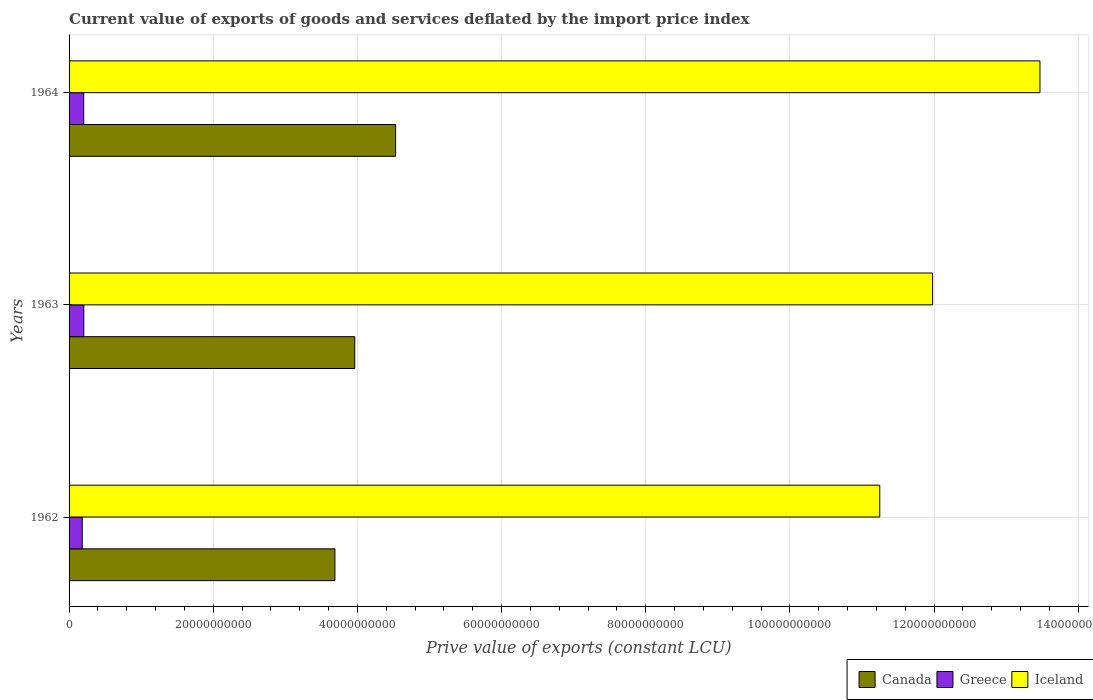How many different coloured bars are there?
Make the answer very short. 3. What is the label of the 2nd group of bars from the top?
Your answer should be very brief. 1963. What is the prive value of exports in Greece in 1963?
Provide a succinct answer. 2.04e+09. Across all years, what is the maximum prive value of exports in Canada?
Provide a short and direct response. 4.53e+1. Across all years, what is the minimum prive value of exports in Canada?
Provide a short and direct response. 3.69e+1. In which year was the prive value of exports in Greece maximum?
Your answer should be compact. 1963. What is the total prive value of exports in Iceland in the graph?
Keep it short and to the point. 3.67e+11. What is the difference between the prive value of exports in Iceland in 1962 and that in 1964?
Offer a very short reply. -2.22e+1. What is the difference between the prive value of exports in Canada in 1964 and the prive value of exports in Greece in 1963?
Give a very brief answer. 4.33e+1. What is the average prive value of exports in Canada per year?
Your answer should be very brief. 4.06e+1. In the year 1963, what is the difference between the prive value of exports in Canada and prive value of exports in Greece?
Keep it short and to the point. 3.76e+1. In how many years, is the prive value of exports in Greece greater than 44000000000 LCU?
Provide a succinct answer. 0. What is the ratio of the prive value of exports in Canada in 1963 to that in 1964?
Provide a short and direct response. 0.87. Is the prive value of exports in Iceland in 1963 less than that in 1964?
Ensure brevity in your answer.  Yes. What is the difference between the highest and the second highest prive value of exports in Greece?
Offer a terse response. 9.09e+06. What is the difference between the highest and the lowest prive value of exports in Iceland?
Give a very brief answer. 2.22e+1. In how many years, is the prive value of exports in Iceland greater than the average prive value of exports in Iceland taken over all years?
Your answer should be compact. 1. What does the 3rd bar from the bottom in 1964 represents?
Keep it short and to the point. Iceland. Is it the case that in every year, the sum of the prive value of exports in Iceland and prive value of exports in Greece is greater than the prive value of exports in Canada?
Your answer should be compact. Yes. How many bars are there?
Provide a short and direct response. 9. Are all the bars in the graph horizontal?
Provide a succinct answer. Yes. How many years are there in the graph?
Make the answer very short. 3. Are the values on the major ticks of X-axis written in scientific E-notation?
Offer a terse response. No. Does the graph contain any zero values?
Offer a terse response. No. Does the graph contain grids?
Your response must be concise. Yes. Where does the legend appear in the graph?
Ensure brevity in your answer.  Bottom right. How many legend labels are there?
Keep it short and to the point. 3. What is the title of the graph?
Offer a terse response. Current value of exports of goods and services deflated by the import price index. Does "Denmark" appear as one of the legend labels in the graph?
Make the answer very short. No. What is the label or title of the X-axis?
Your response must be concise. Prive value of exports (constant LCU). What is the label or title of the Y-axis?
Provide a short and direct response. Years. What is the Prive value of exports (constant LCU) in Canada in 1962?
Ensure brevity in your answer.  3.69e+1. What is the Prive value of exports (constant LCU) of Greece in 1962?
Your response must be concise. 1.83e+09. What is the Prive value of exports (constant LCU) in Iceland in 1962?
Make the answer very short. 1.12e+11. What is the Prive value of exports (constant LCU) in Canada in 1963?
Offer a very short reply. 3.96e+1. What is the Prive value of exports (constant LCU) of Greece in 1963?
Offer a terse response. 2.04e+09. What is the Prive value of exports (constant LCU) in Iceland in 1963?
Offer a very short reply. 1.20e+11. What is the Prive value of exports (constant LCU) of Canada in 1964?
Offer a terse response. 4.53e+1. What is the Prive value of exports (constant LCU) in Greece in 1964?
Your response must be concise. 2.03e+09. What is the Prive value of exports (constant LCU) in Iceland in 1964?
Your answer should be very brief. 1.35e+11. Across all years, what is the maximum Prive value of exports (constant LCU) in Canada?
Your answer should be very brief. 4.53e+1. Across all years, what is the maximum Prive value of exports (constant LCU) in Greece?
Provide a succinct answer. 2.04e+09. Across all years, what is the maximum Prive value of exports (constant LCU) in Iceland?
Your answer should be very brief. 1.35e+11. Across all years, what is the minimum Prive value of exports (constant LCU) of Canada?
Give a very brief answer. 3.69e+1. Across all years, what is the minimum Prive value of exports (constant LCU) in Greece?
Keep it short and to the point. 1.83e+09. Across all years, what is the minimum Prive value of exports (constant LCU) in Iceland?
Your answer should be compact. 1.12e+11. What is the total Prive value of exports (constant LCU) of Canada in the graph?
Ensure brevity in your answer.  1.22e+11. What is the total Prive value of exports (constant LCU) of Greece in the graph?
Ensure brevity in your answer.  5.90e+09. What is the total Prive value of exports (constant LCU) of Iceland in the graph?
Provide a succinct answer. 3.67e+11. What is the difference between the Prive value of exports (constant LCU) in Canada in 1962 and that in 1963?
Make the answer very short. -2.75e+09. What is the difference between the Prive value of exports (constant LCU) of Greece in 1962 and that in 1963?
Ensure brevity in your answer.  -2.17e+08. What is the difference between the Prive value of exports (constant LCU) in Iceland in 1962 and that in 1963?
Give a very brief answer. -7.33e+09. What is the difference between the Prive value of exports (constant LCU) in Canada in 1962 and that in 1964?
Provide a succinct answer. -8.42e+09. What is the difference between the Prive value of exports (constant LCU) in Greece in 1962 and that in 1964?
Your answer should be very brief. -2.08e+08. What is the difference between the Prive value of exports (constant LCU) in Iceland in 1962 and that in 1964?
Offer a very short reply. -2.22e+1. What is the difference between the Prive value of exports (constant LCU) in Canada in 1963 and that in 1964?
Provide a succinct answer. -5.67e+09. What is the difference between the Prive value of exports (constant LCU) of Greece in 1963 and that in 1964?
Provide a succinct answer. 9.09e+06. What is the difference between the Prive value of exports (constant LCU) in Iceland in 1963 and that in 1964?
Make the answer very short. -1.49e+1. What is the difference between the Prive value of exports (constant LCU) in Canada in 1962 and the Prive value of exports (constant LCU) in Greece in 1963?
Give a very brief answer. 3.48e+1. What is the difference between the Prive value of exports (constant LCU) of Canada in 1962 and the Prive value of exports (constant LCU) of Iceland in 1963?
Provide a short and direct response. -8.29e+1. What is the difference between the Prive value of exports (constant LCU) of Greece in 1962 and the Prive value of exports (constant LCU) of Iceland in 1963?
Make the answer very short. -1.18e+11. What is the difference between the Prive value of exports (constant LCU) of Canada in 1962 and the Prive value of exports (constant LCU) of Greece in 1964?
Provide a succinct answer. 3.48e+1. What is the difference between the Prive value of exports (constant LCU) of Canada in 1962 and the Prive value of exports (constant LCU) of Iceland in 1964?
Make the answer very short. -9.78e+1. What is the difference between the Prive value of exports (constant LCU) in Greece in 1962 and the Prive value of exports (constant LCU) in Iceland in 1964?
Your answer should be compact. -1.33e+11. What is the difference between the Prive value of exports (constant LCU) in Canada in 1963 and the Prive value of exports (constant LCU) in Greece in 1964?
Ensure brevity in your answer.  3.76e+1. What is the difference between the Prive value of exports (constant LCU) of Canada in 1963 and the Prive value of exports (constant LCU) of Iceland in 1964?
Give a very brief answer. -9.51e+1. What is the difference between the Prive value of exports (constant LCU) of Greece in 1963 and the Prive value of exports (constant LCU) of Iceland in 1964?
Make the answer very short. -1.33e+11. What is the average Prive value of exports (constant LCU) in Canada per year?
Offer a terse response. 4.06e+1. What is the average Prive value of exports (constant LCU) in Greece per year?
Provide a succinct answer. 1.97e+09. What is the average Prive value of exports (constant LCU) of Iceland per year?
Offer a terse response. 1.22e+11. In the year 1962, what is the difference between the Prive value of exports (constant LCU) of Canada and Prive value of exports (constant LCU) of Greece?
Make the answer very short. 3.51e+1. In the year 1962, what is the difference between the Prive value of exports (constant LCU) of Canada and Prive value of exports (constant LCU) of Iceland?
Your answer should be compact. -7.56e+1. In the year 1962, what is the difference between the Prive value of exports (constant LCU) of Greece and Prive value of exports (constant LCU) of Iceland?
Give a very brief answer. -1.11e+11. In the year 1963, what is the difference between the Prive value of exports (constant LCU) in Canada and Prive value of exports (constant LCU) in Greece?
Provide a short and direct response. 3.76e+1. In the year 1963, what is the difference between the Prive value of exports (constant LCU) in Canada and Prive value of exports (constant LCU) in Iceland?
Provide a succinct answer. -8.02e+1. In the year 1963, what is the difference between the Prive value of exports (constant LCU) of Greece and Prive value of exports (constant LCU) of Iceland?
Offer a terse response. -1.18e+11. In the year 1964, what is the difference between the Prive value of exports (constant LCU) of Canada and Prive value of exports (constant LCU) of Greece?
Your answer should be very brief. 4.33e+1. In the year 1964, what is the difference between the Prive value of exports (constant LCU) in Canada and Prive value of exports (constant LCU) in Iceland?
Provide a succinct answer. -8.94e+1. In the year 1964, what is the difference between the Prive value of exports (constant LCU) of Greece and Prive value of exports (constant LCU) of Iceland?
Keep it short and to the point. -1.33e+11. What is the ratio of the Prive value of exports (constant LCU) in Canada in 1962 to that in 1963?
Ensure brevity in your answer.  0.93. What is the ratio of the Prive value of exports (constant LCU) of Greece in 1962 to that in 1963?
Provide a succinct answer. 0.89. What is the ratio of the Prive value of exports (constant LCU) in Iceland in 1962 to that in 1963?
Offer a terse response. 0.94. What is the ratio of the Prive value of exports (constant LCU) in Canada in 1962 to that in 1964?
Make the answer very short. 0.81. What is the ratio of the Prive value of exports (constant LCU) of Greece in 1962 to that in 1964?
Ensure brevity in your answer.  0.9. What is the ratio of the Prive value of exports (constant LCU) of Iceland in 1962 to that in 1964?
Make the answer very short. 0.83. What is the ratio of the Prive value of exports (constant LCU) of Canada in 1963 to that in 1964?
Offer a very short reply. 0.87. What is the ratio of the Prive value of exports (constant LCU) of Greece in 1963 to that in 1964?
Provide a succinct answer. 1. What is the ratio of the Prive value of exports (constant LCU) of Iceland in 1963 to that in 1964?
Keep it short and to the point. 0.89. What is the difference between the highest and the second highest Prive value of exports (constant LCU) of Canada?
Your response must be concise. 5.67e+09. What is the difference between the highest and the second highest Prive value of exports (constant LCU) in Greece?
Your response must be concise. 9.09e+06. What is the difference between the highest and the second highest Prive value of exports (constant LCU) of Iceland?
Make the answer very short. 1.49e+1. What is the difference between the highest and the lowest Prive value of exports (constant LCU) of Canada?
Keep it short and to the point. 8.42e+09. What is the difference between the highest and the lowest Prive value of exports (constant LCU) of Greece?
Provide a succinct answer. 2.17e+08. What is the difference between the highest and the lowest Prive value of exports (constant LCU) of Iceland?
Give a very brief answer. 2.22e+1. 